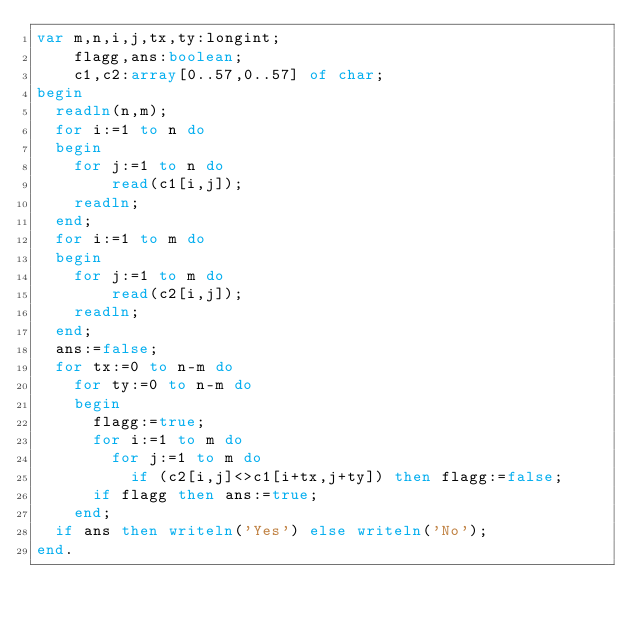<code> <loc_0><loc_0><loc_500><loc_500><_Pascal_>var m,n,i,j,tx,ty:longint;
    flagg,ans:boolean;
	c1,c2:array[0..57,0..57] of char;
begin
  readln(n,m);
  for i:=1 to n do
  begin
    for j:=1 to n do
		read(c1[i,j]);
	readln;
  end;
  for i:=1 to m do
  begin
    for j:=1 to m do
		read(c2[i,j]);
	readln;
  end;
  ans:=false;
  for tx:=0 to n-m do
	for ty:=0 to n-m do
	begin
	  flagg:=true;
	  for i:=1 to m do
		for j:=1 to m do
		  if (c2[i,j]<>c1[i+tx,j+ty]) then flagg:=false;
	  if flagg then ans:=true;
	end;
  if ans then writeln('Yes') else writeln('No');
end.
  </code> 